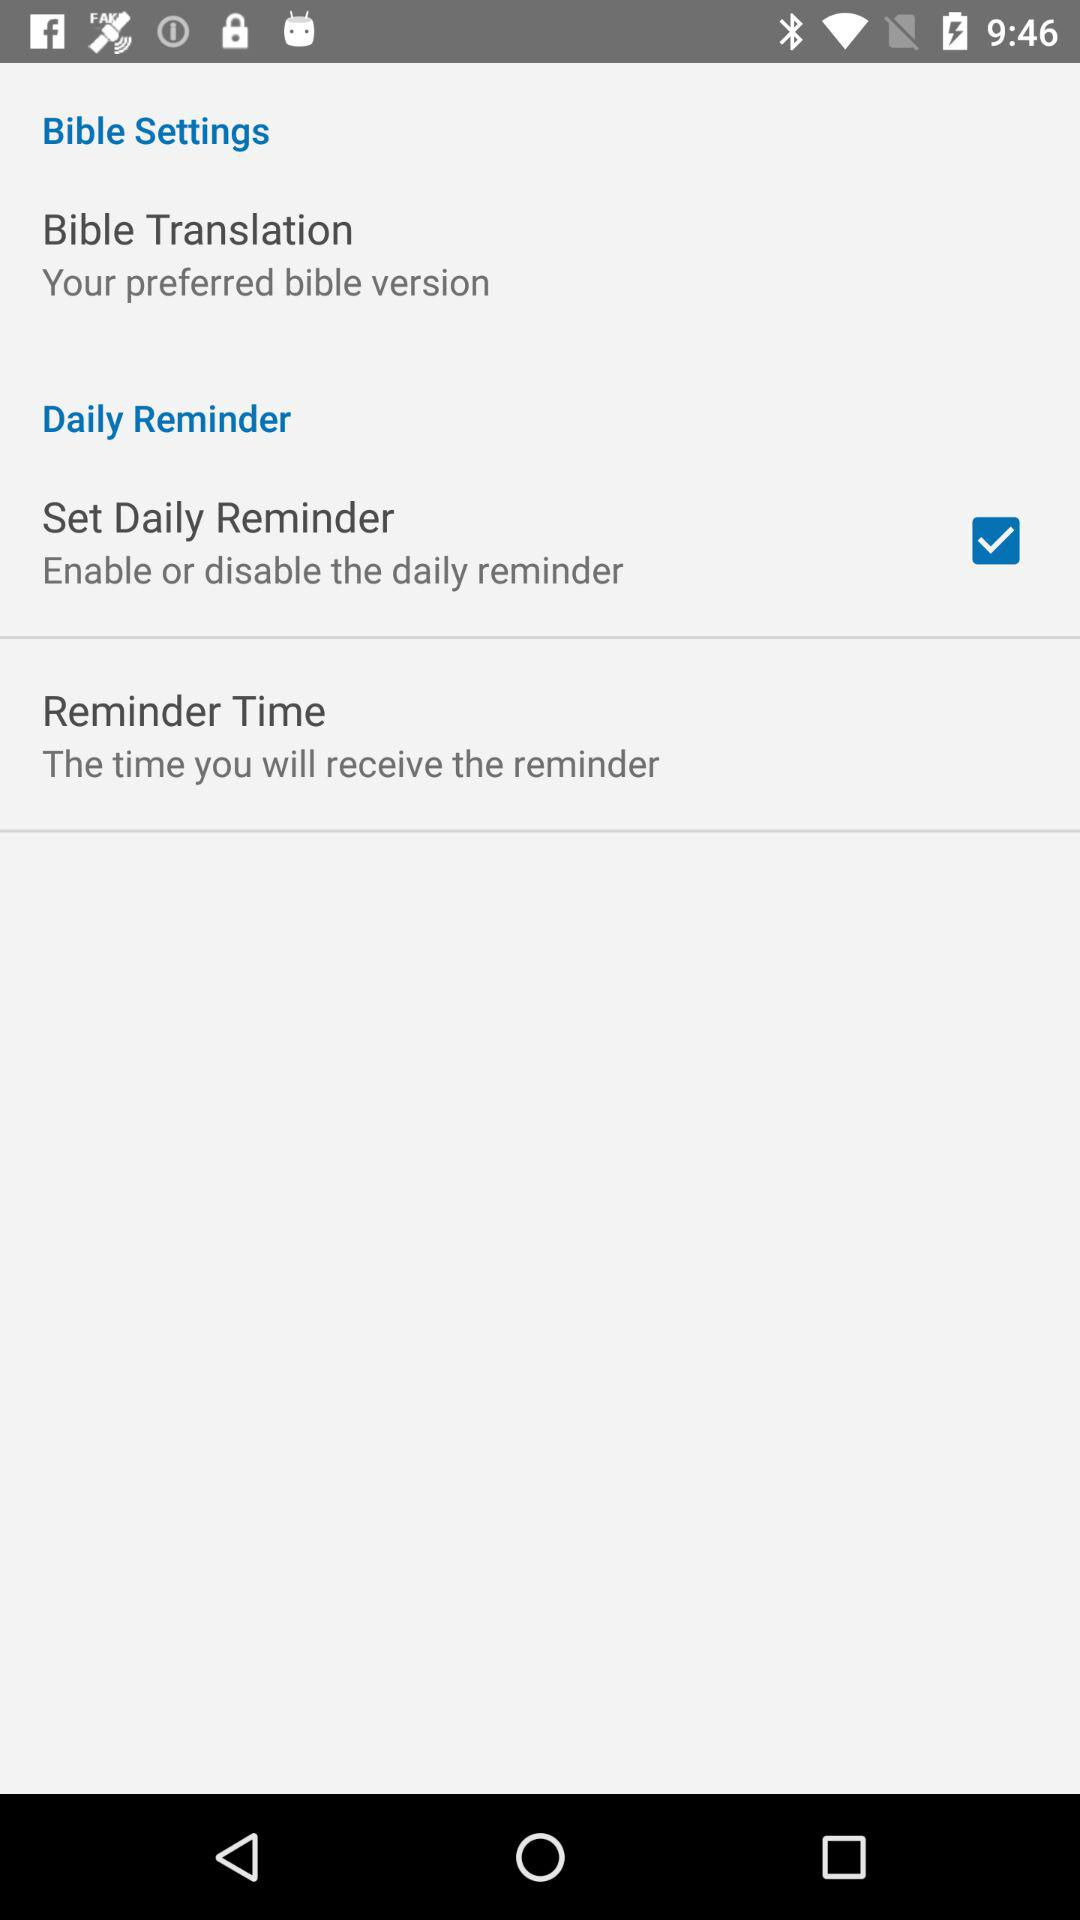How many items are under the Daily Reminder section?
Answer the question using a single word or phrase. 2 